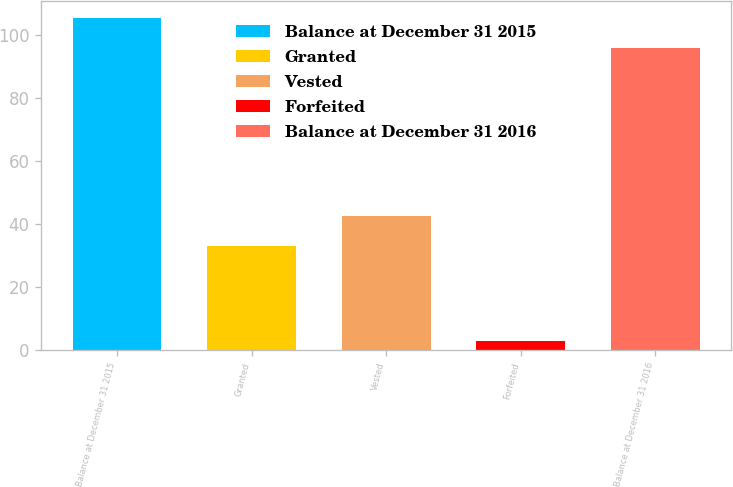<chart> <loc_0><loc_0><loc_500><loc_500><bar_chart><fcel>Balance at December 31 2015<fcel>Granted<fcel>Vested<fcel>Forfeited<fcel>Balance at December 31 2016<nl><fcel>105.6<fcel>33<fcel>42.6<fcel>3<fcel>96<nl></chart> 